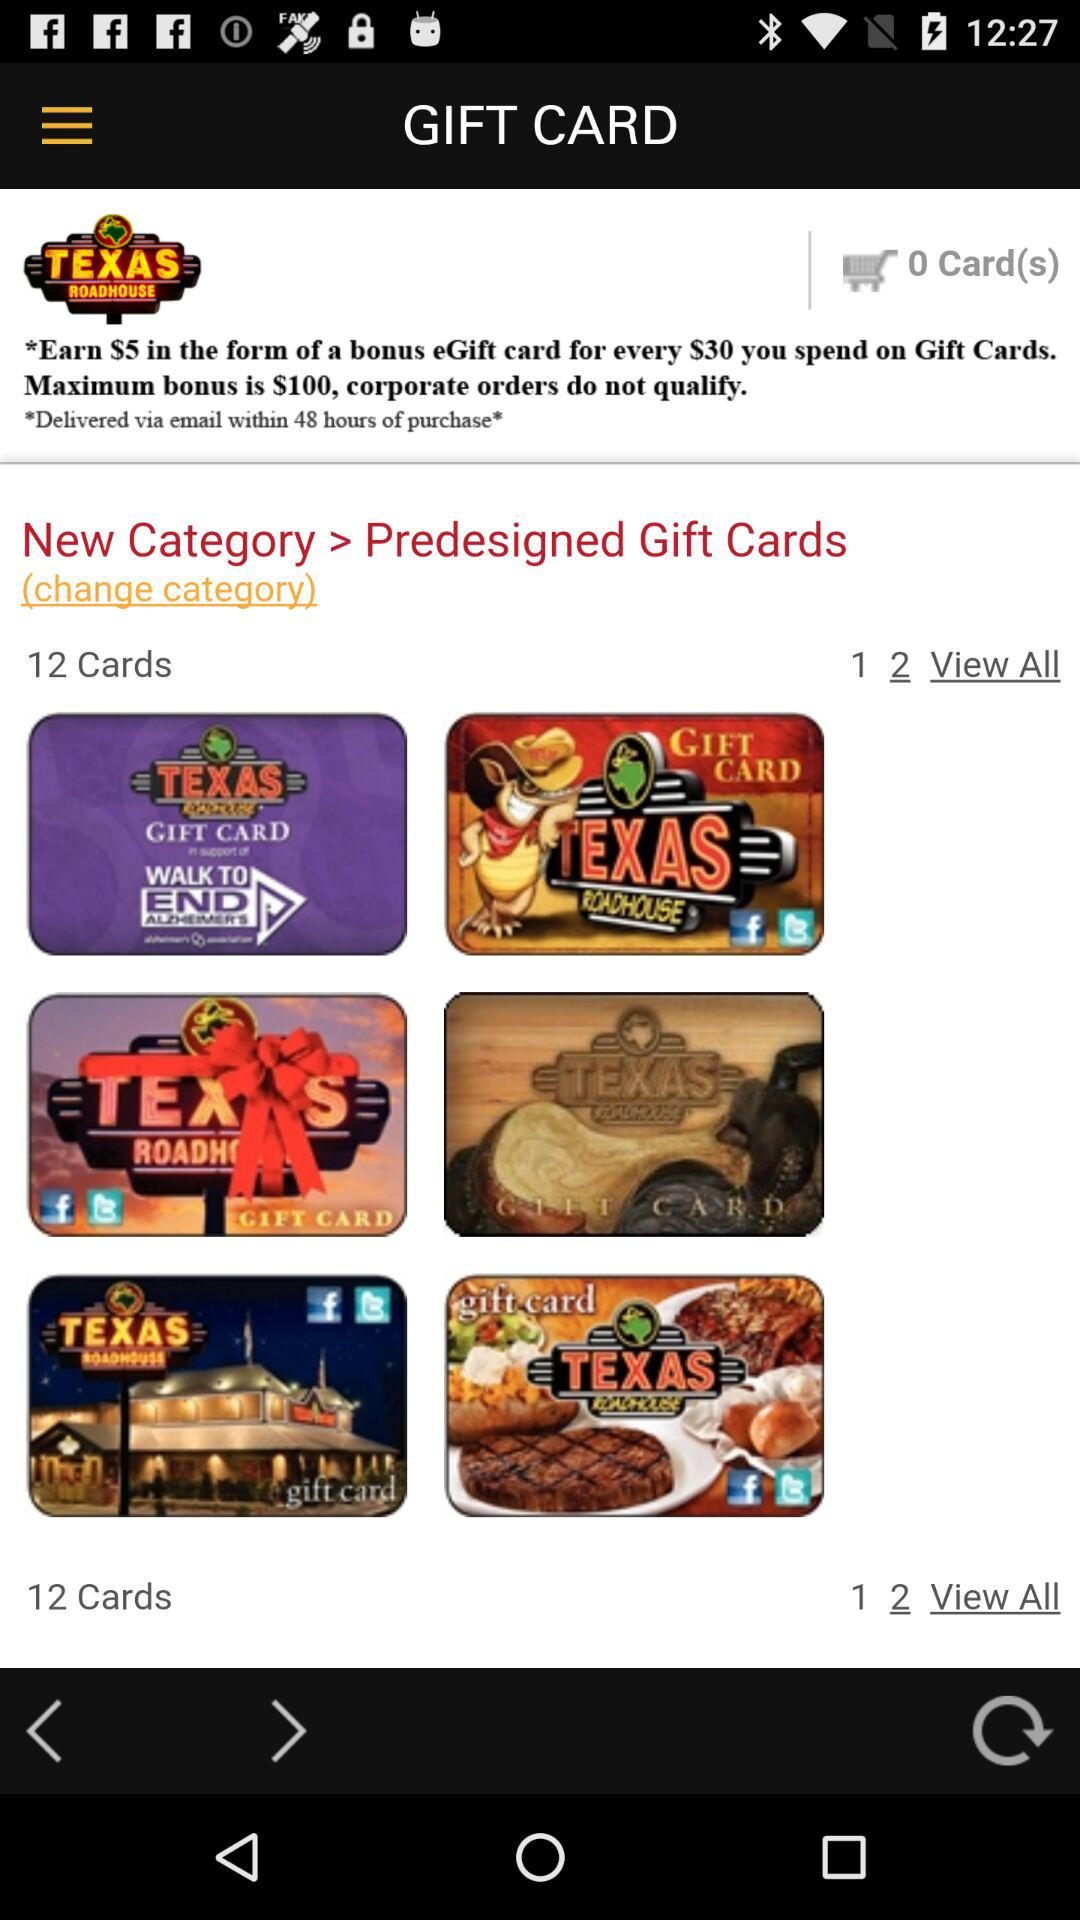When will the Gift Card be delivered after purchase? The Gift Card will be delivered within 48 hours of purchase. 